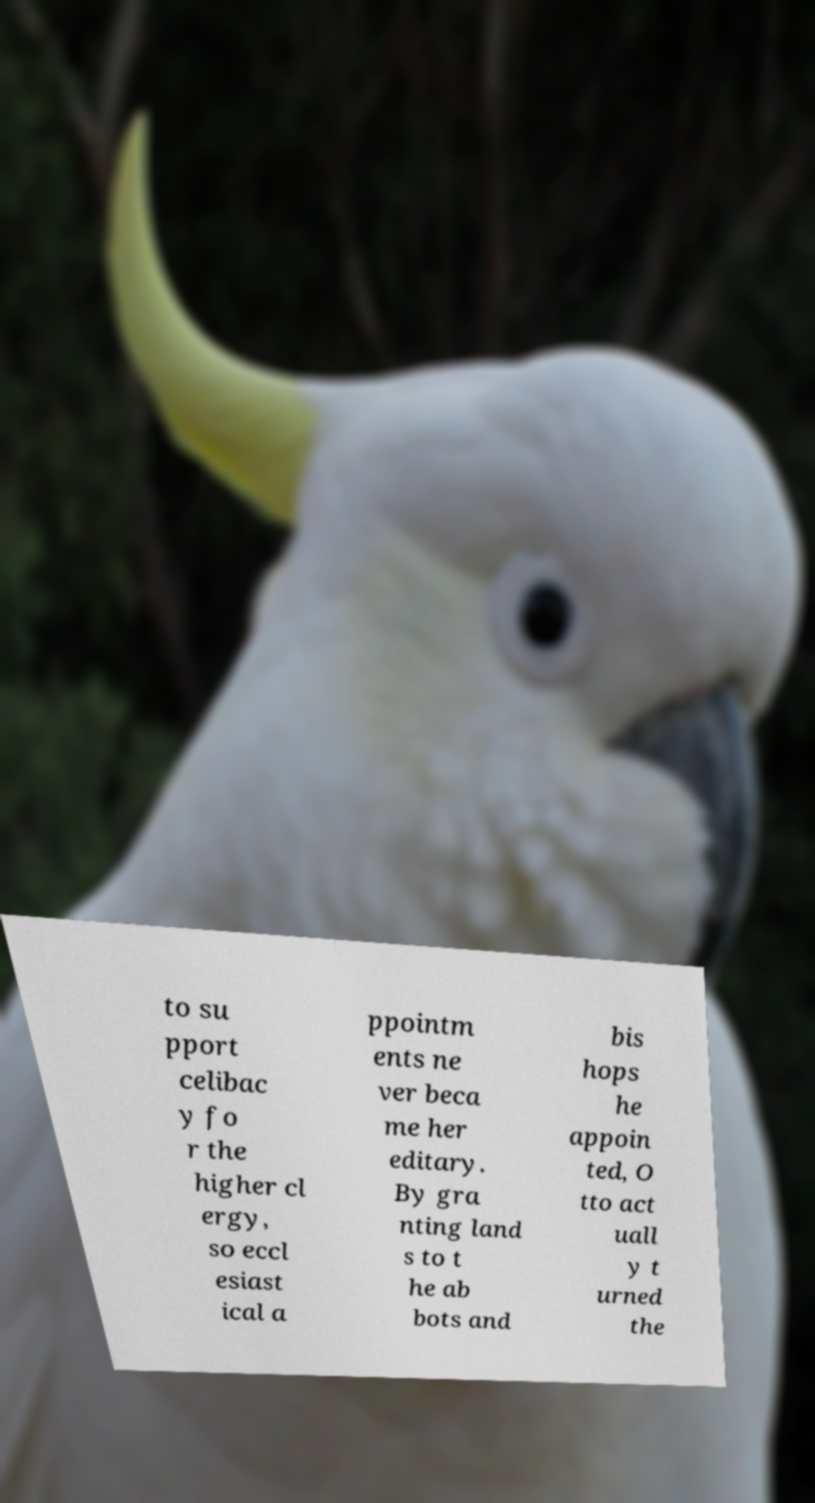Could you extract and type out the text from this image? to su pport celibac y fo r the higher cl ergy, so eccl esiast ical a ppointm ents ne ver beca me her editary. By gra nting land s to t he ab bots and bis hops he appoin ted, O tto act uall y t urned the 